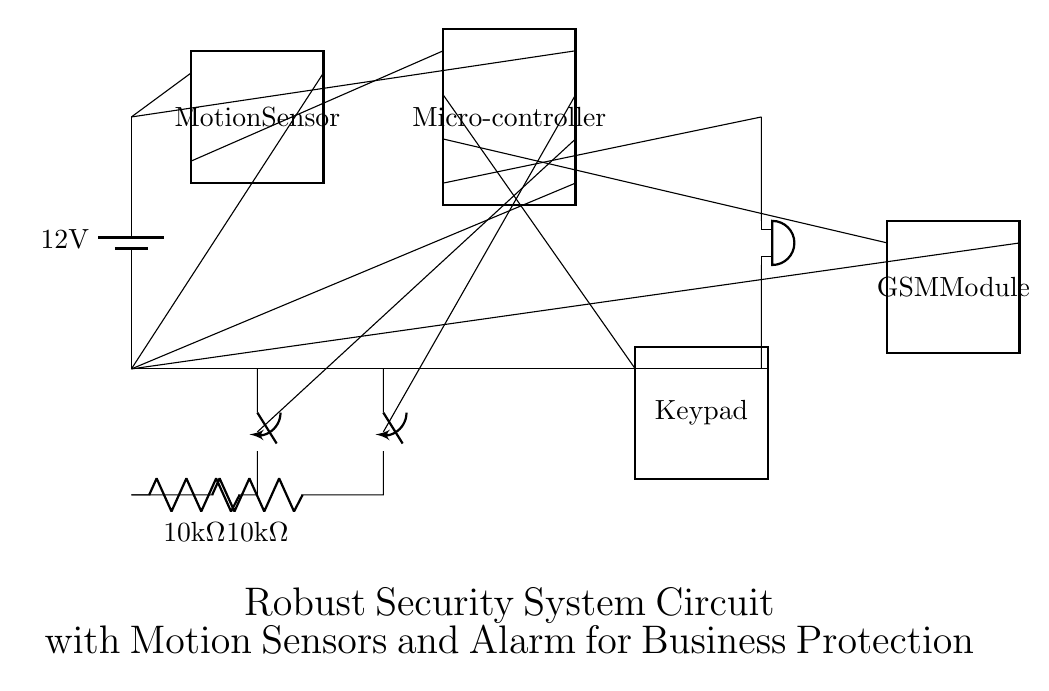What is the voltage of this circuit? The circuit uses a battery symbol indicating a voltage source, which specifies a voltage of twelve volts.
Answer: twelve volts What components connect to the microcontroller? The microcontroller in the circuit is connected to the motion sensor, door sensor, window sensor, keypad, and GSM module, demonstrating its role as a central processing unit.
Answer: motion sensor, door sensor, window sensor, keypad, GSM module What type of sensor is used for motion detection? The diagram shows a dipchip labeled as a motion sensor, indicating the type of sensor employed for detecting motion within the security system.
Answer: motion sensor What is the resistance value across the door and window sensors? Both sensors are connected to a resistor labeled as ten kilohms, indicating their resistance value when activated in the circuit.
Answer: ten kilohms Which component is responsible for triggering the alarm? The buzzer, positioned at the end of the alarm path in the circuit, is directly controlled by the microcontroller, thus triggering the alarm when a sensor detects motion or unauthorized access.
Answer: buzzer What role does the GSM module play in the circuit? The GSM module connects to the microcontroller and is typically used to send notifications or alerts to a mobile device, thereby enhancing the security response to intrusions.
Answer: notifications 